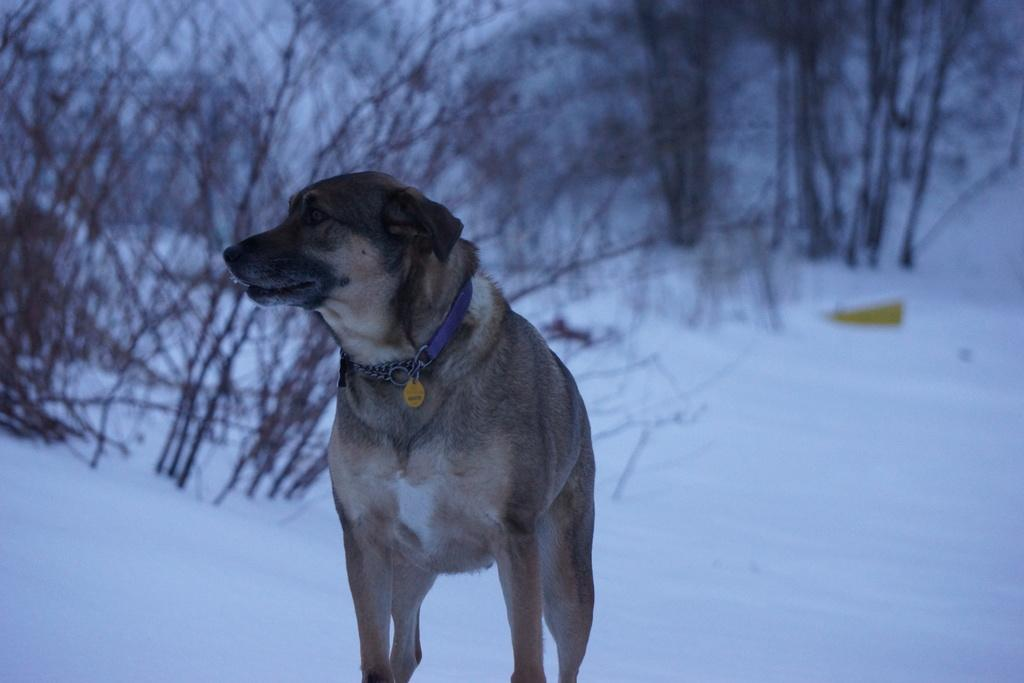What animal is standing in the image? There is a dog standing in the image. What can be seen around the dog's waist? There is a blue color belt in the image. What is covering the ground in the image? The ground is covered in snow. What type of natural environment can be seen in the image? There are trees visible in the image. What type of appliance is being used to prepare breakfast in the image? There is no appliance or mention of breakfast in the image; it features a dog standing with a blue color belt, snow-covered ground, and trees. 